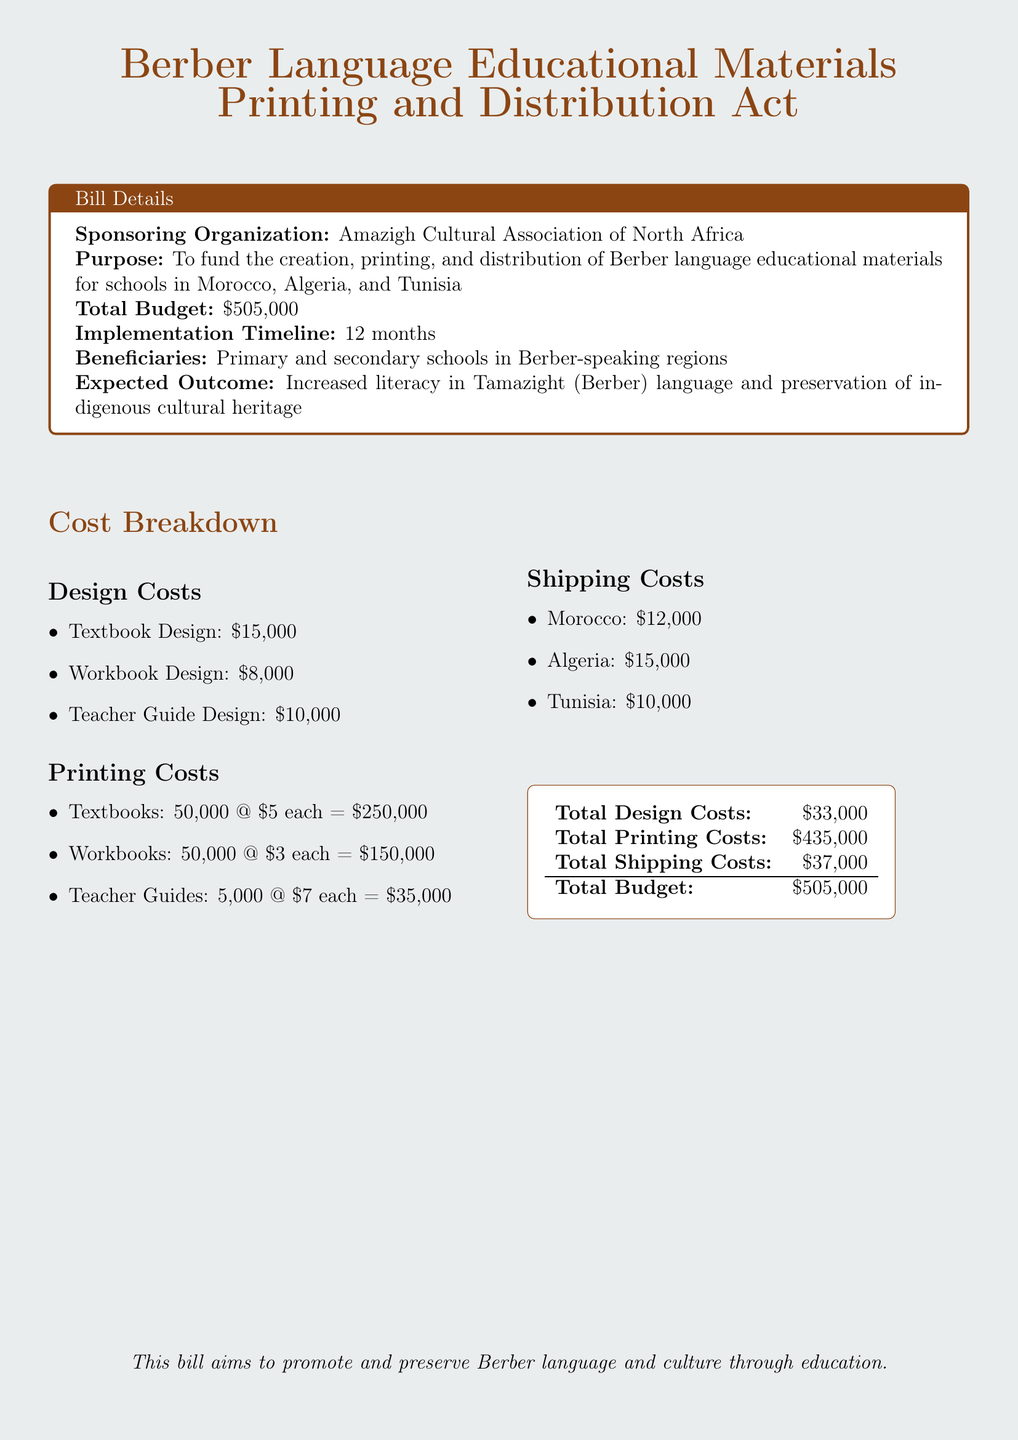What is the sponsoring organization? The organization that is sponsoring the bill is mentioned in the document as the Amazigh Cultural Association of North Africa.
Answer: Amazigh Cultural Association of North Africa What is the total budget? The document specifies the total budget allocated for the bill, which is listed directly as $505,000.
Answer: $505,000 What are the shipping costs to Algeria? The shipping costs specifically for Algeria are detailed in the document, which states $15,000.
Answer: $15,000 What is the design cost for teacher guides? The document provides the specific cost for designing teacher guides as $10,000.
Answer: $10,000 How many textbooks are planned for printing? The document indicates that the planned number of textbooks to be printed is 50,000.
Answer: 50,000 What is the expected outcome of the bill? The expected outcome mentioned in the document is the increased literacy in the Tamazight language and preservation of indigenous cultural heritage.
Answer: Increased literacy in Tamazight and preservation of indigenous cultural heritage What is the implementation timeline of the bill? The timeline for implementing the bill is specified in the document as 12 months.
Answer: 12 months What is the total printing cost? The document summarizes the total printing costs as $435,000.
Answer: $435,000 